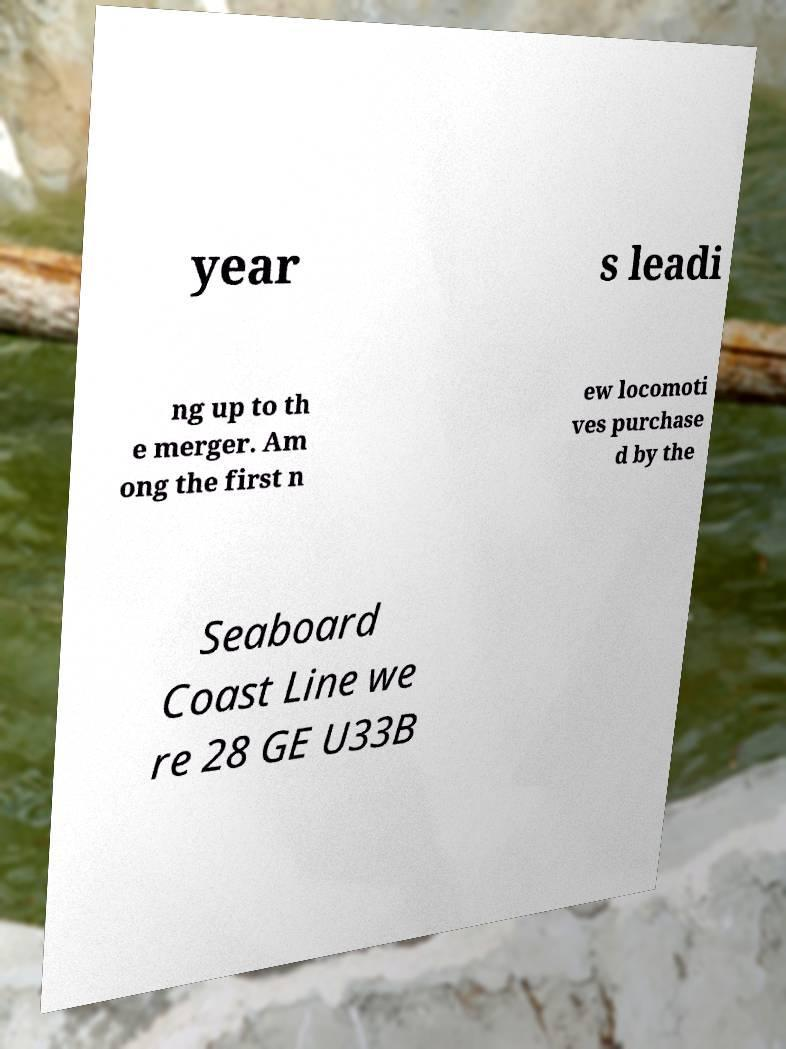Please identify and transcribe the text found in this image. year s leadi ng up to th e merger. Am ong the first n ew locomoti ves purchase d by the Seaboard Coast Line we re 28 GE U33B 